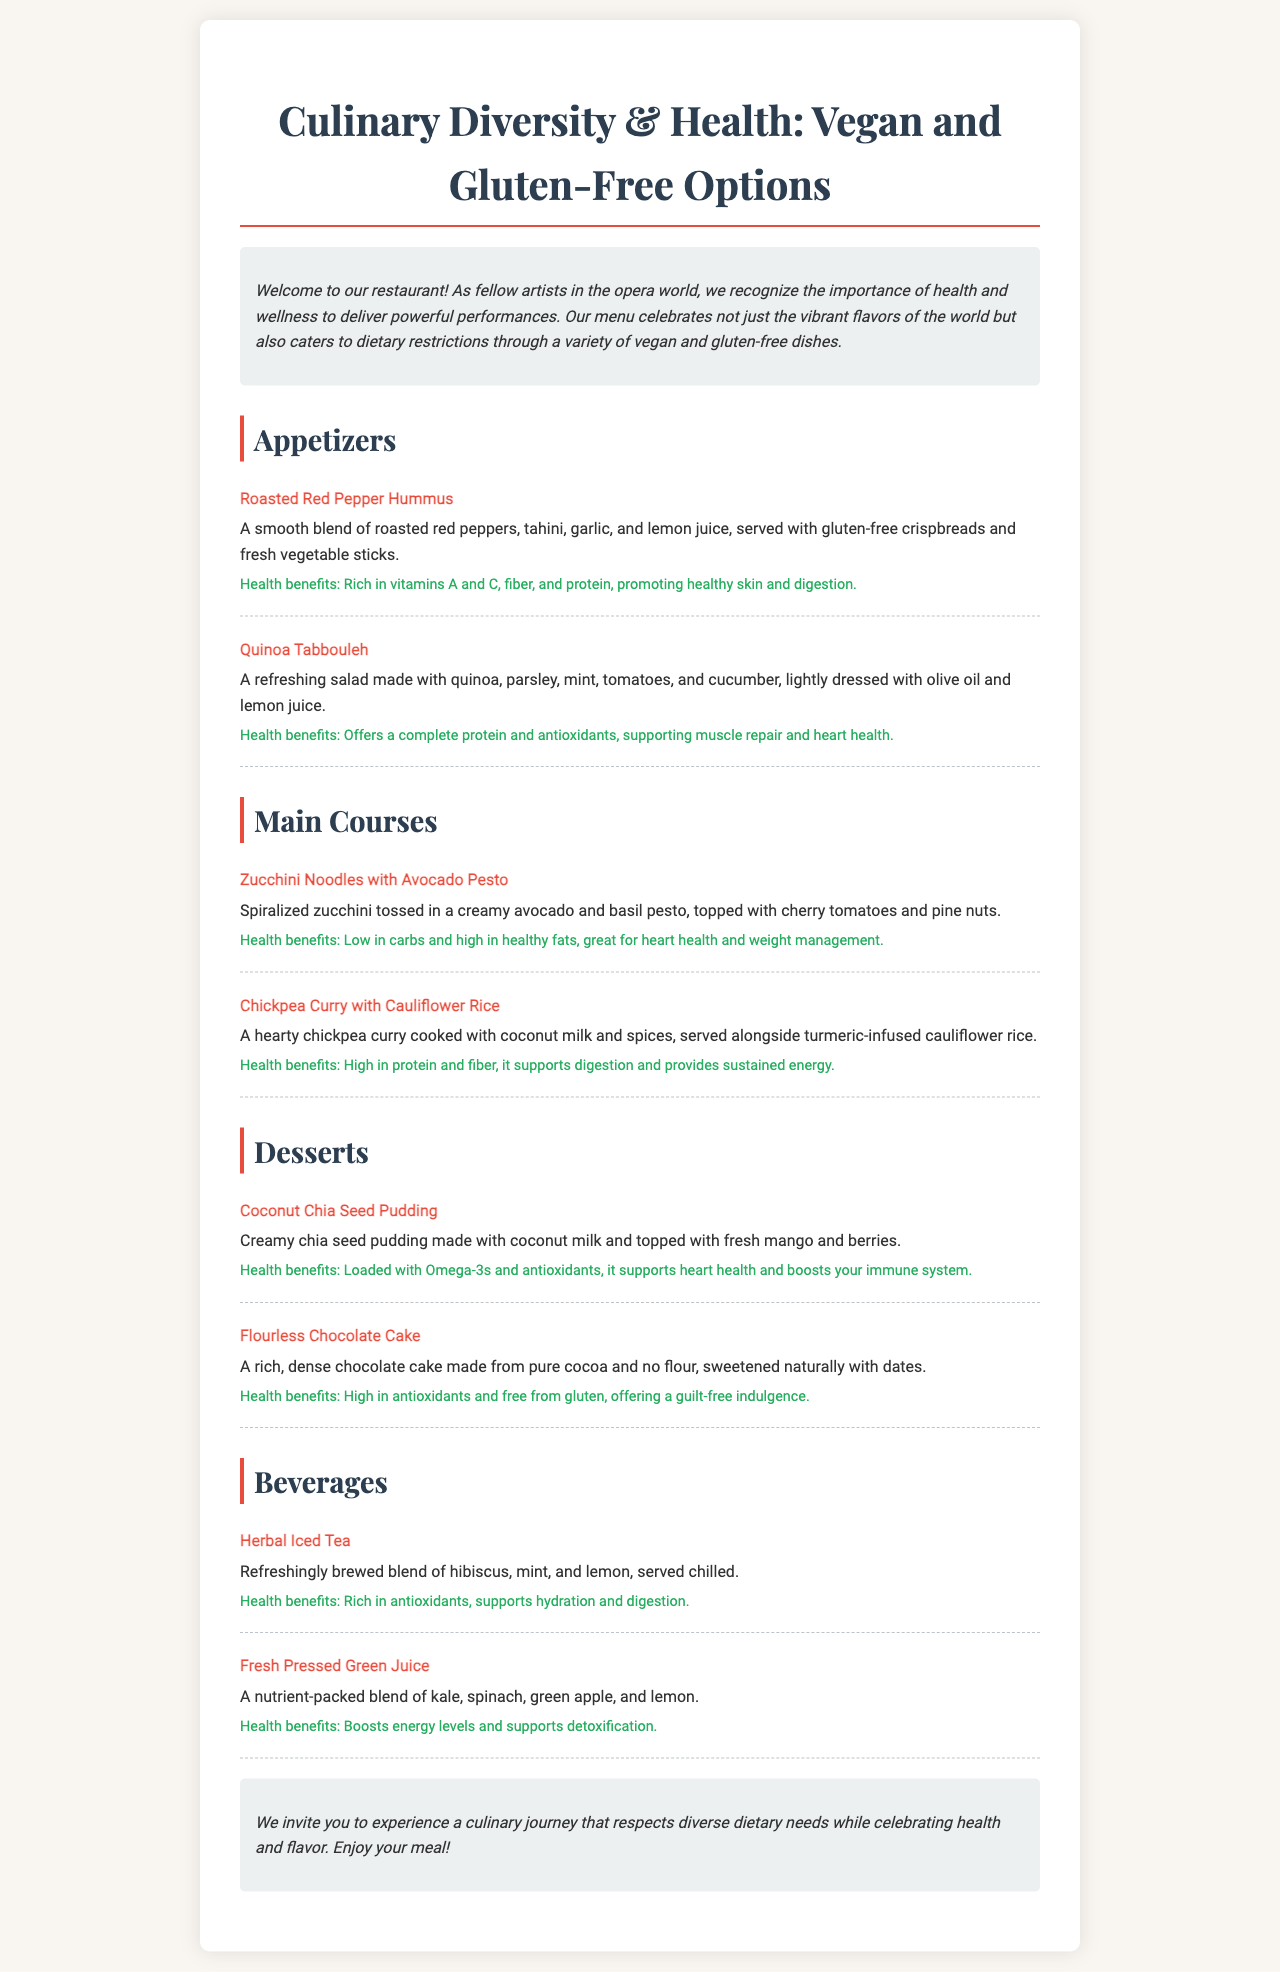what is the title of the menu? The title of the menu is presented at the top of the document, which is "Culinary Diversity & Health: Vegan and Gluten-Free Options."
Answer: Culinary Diversity & Health: Vegan and Gluten-Free Options how many appetizers are listed on the menu? The menu lists a total of two appetizers in the appetizers section.
Answer: 2 what is the first dessert mentioned on the menu? The first dessert listed in the desserts section is clearly defined, which is "Coconut Chia Seed Pudding."
Answer: Coconut Chia Seed Pudding what health benefit is associated with the Roasted Red Pepper Hummus? The health benefits section for Roasted Red Pepper Hummus specifies that it is "Rich in vitamins A and C, fiber, and protein, promoting healthy skin and digestion."
Answer: Rich in vitamins A and C, fiber, and protein which beverage promotes hydration and digestion? The health benefits for Herbal Iced Tea indicate that it "supports hydration and digestion."
Answer: Herbal Iced Tea what are the main ingredients in the Flourless Chocolate Cake? The item description for Flourless Chocolate Cake specifies that it is made from "pure cocoa and no flour, sweetened naturally with dates."
Answer: pure cocoa and no flour, sweetened naturally with dates what is a key characteristic of the Zucchini Noodles with Avocado Pesto? The item description states that it has "spiralized zucchini tossed in a creamy avocado and basil pesto."
Answer: spiralized zucchini tossed in a creamy avocado and basil pesto how is the Coconut Chia Seed Pudding topped? The item description mentions that it is "topped with fresh mango and berries."
Answer: topped with fresh mango and berries 